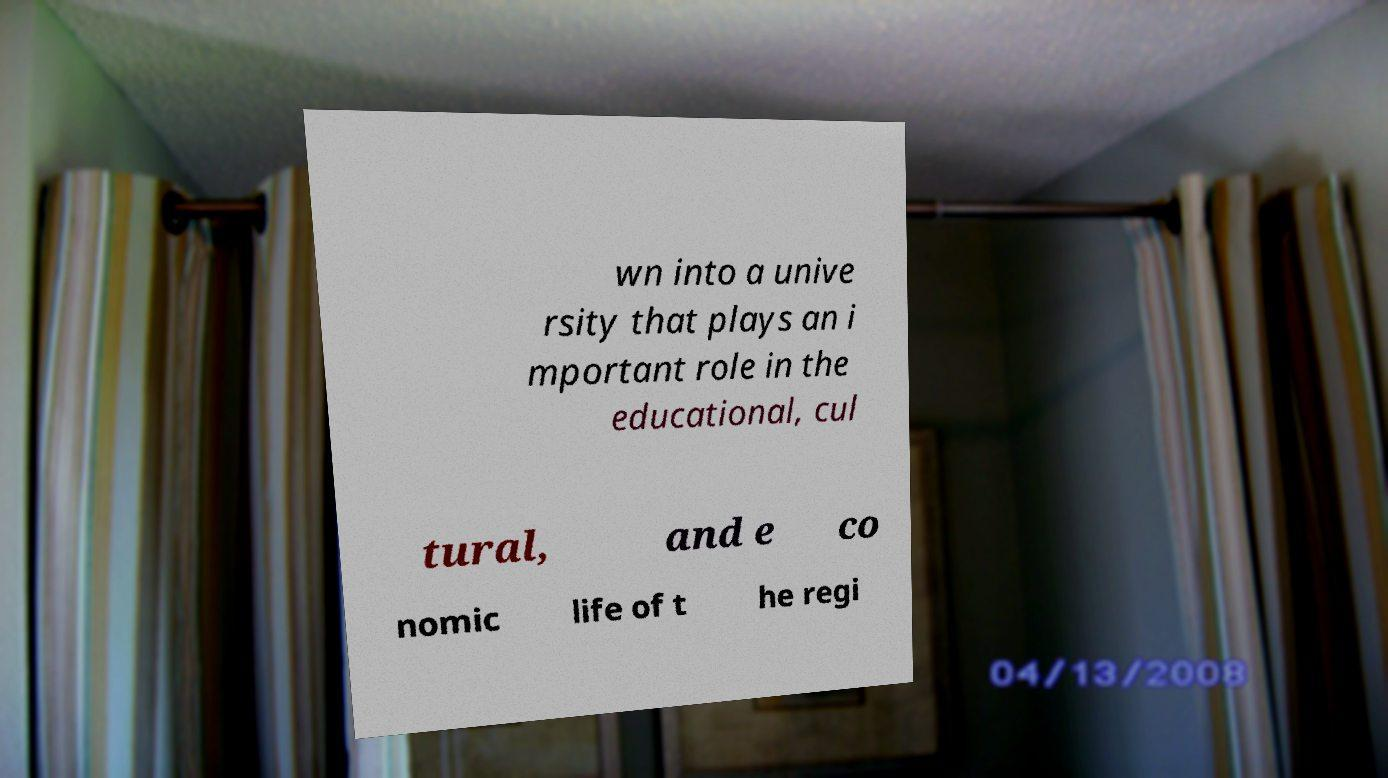Could you extract and type out the text from this image? wn into a unive rsity that plays an i mportant role in the educational, cul tural, and e co nomic life of t he regi 